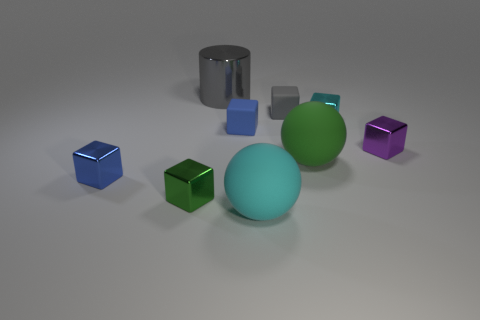What size is the rubber block that is the same color as the cylinder?
Provide a succinct answer. Small. Do the tiny blue block that is behind the small purple metal thing and the green block have the same material?
Make the answer very short. No. How many cylinders are blue things or tiny green objects?
Make the answer very short. 0. The cyan object to the right of the green sphere that is in front of the shiny cube that is right of the tiny cyan object is what shape?
Make the answer very short. Cube. What is the shape of the matte object that is the same color as the metal cylinder?
Keep it short and to the point. Cube. What number of gray things have the same size as the cylinder?
Your response must be concise. 0. There is a tiny blue block on the right side of the blue metal block; are there any gray objects on the right side of it?
Your answer should be compact. Yes. What number of objects are green objects or cyan shiny things?
Your answer should be compact. 3. What is the color of the big matte ball behind the large matte thing in front of the matte sphere behind the big cyan thing?
Your answer should be compact. Green. Is there anything else that has the same color as the big metal object?
Offer a terse response. Yes. 